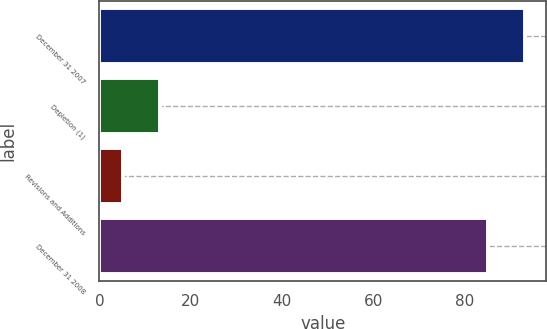<chart> <loc_0><loc_0><loc_500><loc_500><bar_chart><fcel>December 31 2007<fcel>Depletion (1)<fcel>Revisions and Additions<fcel>December 31 2008<nl><fcel>93.13<fcel>13.33<fcel>5.2<fcel>85<nl></chart> 